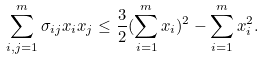Convert formula to latex. <formula><loc_0><loc_0><loc_500><loc_500>\sum _ { i , j = 1 } ^ { m } \sigma _ { i j } x _ { i } x _ { j } \leq \frac { 3 } { 2 } ( \sum _ { i = 1 } ^ { m } x _ { i } ) ^ { 2 } - \sum _ { i = 1 } ^ { m } x _ { i } ^ { 2 } .</formula> 